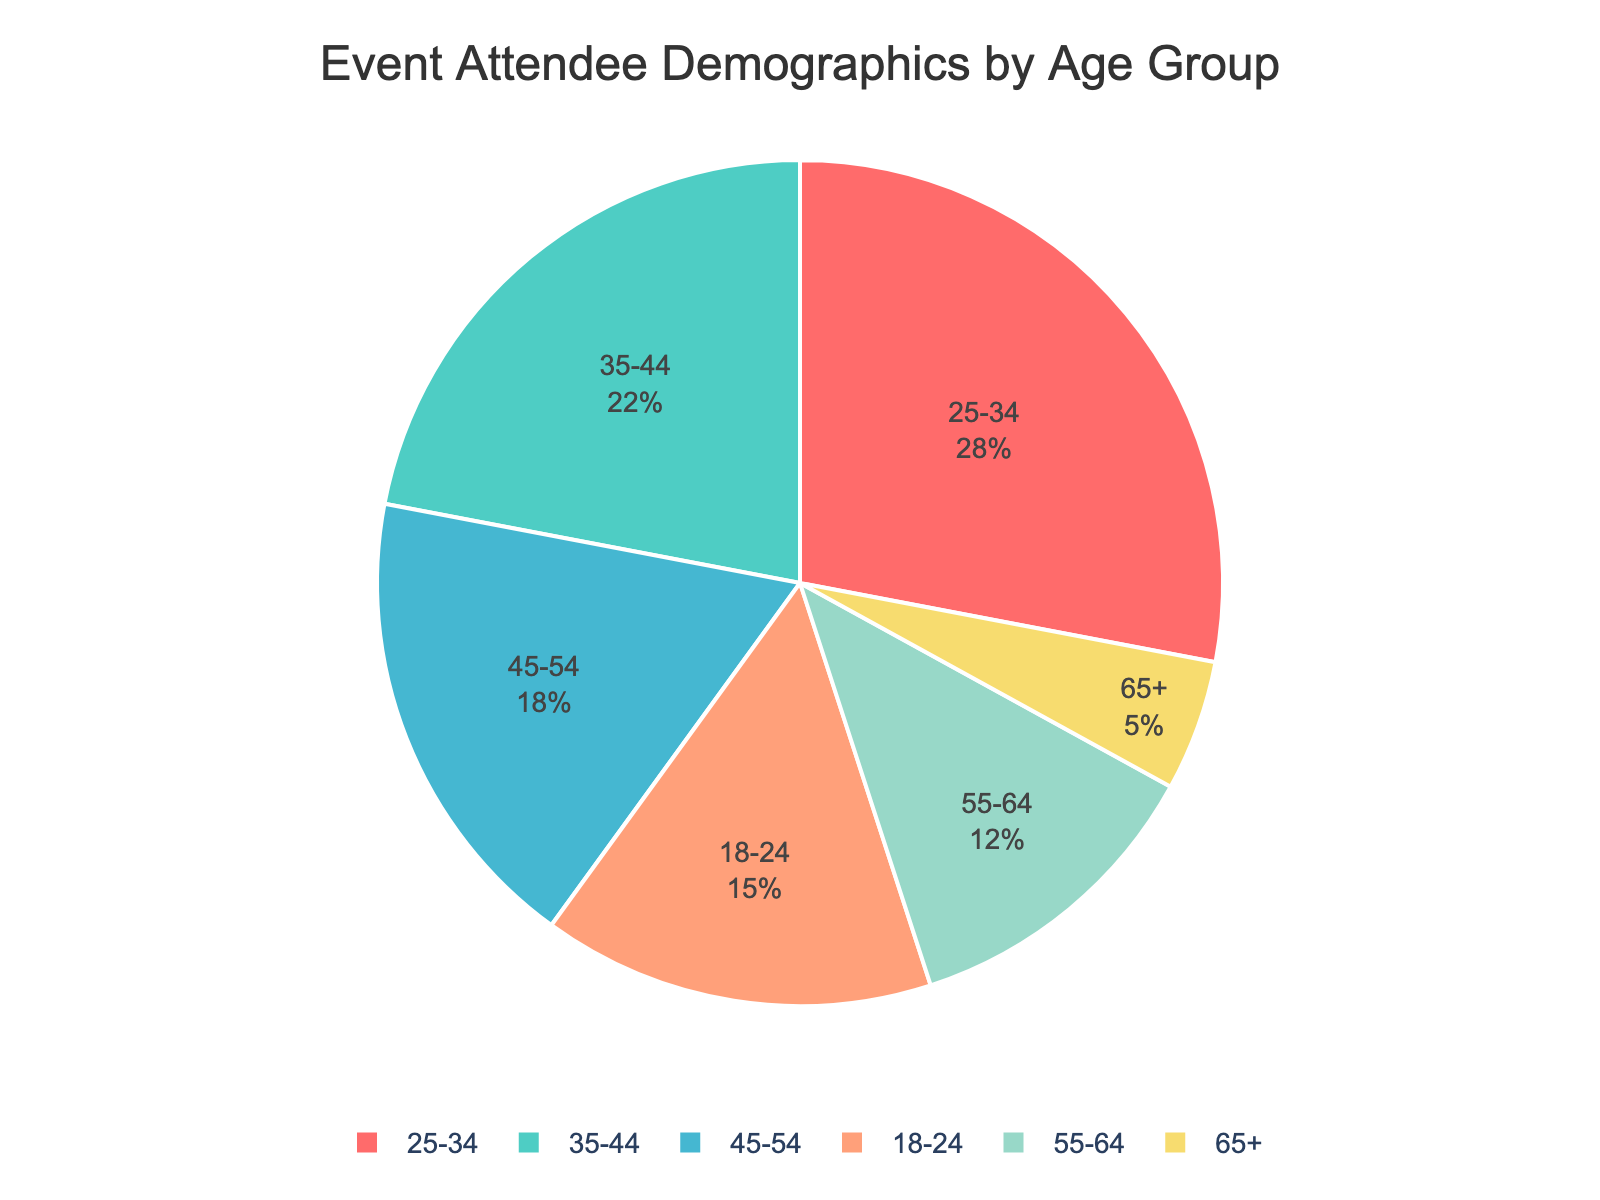What age group constitutes the largest percentage of event attendees? The pie chart shows different age groups and their respective percentages. The age group with the largest segment is labeled "25-34" with a percentage of 28%.
Answer: 25-34 By how much does the percentage of attendees aged 35-44 exceed those aged 55-64? According to the pie chart, the percentage of attendees aged 35-44 is 22%, whereas the percentage for the 55-64 age group is 12%. Subtracting these gives 22% - 12% = 10%.
Answer: 10% What is the combined percentage of attendees who are either under 25 or over 64? The pie chart shows that attendees aged 18-24 make up 15% and those aged 65+ make up 5%. Adding these together gives 15% + 5% = 20%.
Answer: 20% Is there a larger percentage of attendees aged 45-54 or those aged 55-64? According to the pie chart, attendees aged 45-54 make up 18% and those aged 55-64 make up 12%. 18% is larger than 12%.
Answer: 45-54 What proportion of attendees fall within the age range of 25-54? The age groups within 25-54 are 25-34, 35-44, and 45-54. Their percentages are 28%, 22%, and 18%, respectively. Adding these gives 28% + 22% + 18% = 68%.
Answer: 68% What is the difference in percentages between the youngest and the oldest age groups? The pie chart shows the youngest age group (18-24) at 15% and the oldest age group (65+) at 5%. Subtracting these gives 15% - 5% = 10%.
Answer: 10% Which age group has the smallest percentage of attendees, and what is that percentage? The pie chart illustrates that the smallest segment is labeled "65+" with a percentage of 5%.
Answer: 65+, 5% How does the percentage of attendees aged 25-34 compare to the combined percentage of attendees aged 45-64? The pie chart shows that the percentage of attendees aged 25-34 is 28%. The combined percentage for ages 45-54 and 55-64 is 18% + 12% = 30%. 28% is less than 30%.
Answer: Less What would the percentage be if attendees aged 18-24 and 55-64 were combined into one group? The pie chart shows that attendees aged 18-24 are 15% and those aged 55-64 are 12%. Adding these gives 15% + 12% = 27%.
Answer: 27% Which age group between 35-44 or 45-54 has a higher percentage, and by how much? The pie chart indicates that the percentage for the 35-44 age group is 22%, while for the 45-54 age group, it is 18%. The difference is 22% - 18% = 4%.
Answer: 35-44, 4% 